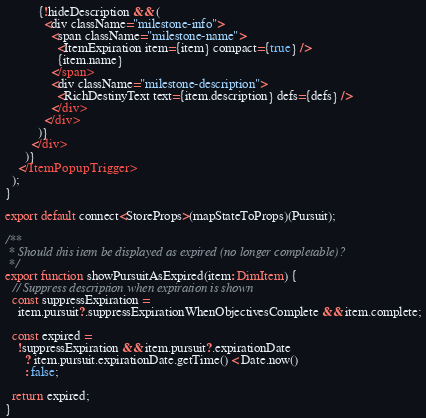Convert code to text. <code><loc_0><loc_0><loc_500><loc_500><_TypeScript_>          {!hideDescription && (
            <div className="milestone-info">
              <span className="milestone-name">
                <ItemExpiration item={item} compact={true} />
                {item.name}
              </span>
              <div className="milestone-description">
                <RichDestinyText text={item.description} defs={defs} />
              </div>
            </div>
          )}
        </div>
      )}
    </ItemPopupTrigger>
  );
}

export default connect<StoreProps>(mapStateToProps)(Pursuit);

/**
 * Should this item be displayed as expired (no longer completable)?
 */
export function showPursuitAsExpired(item: DimItem) {
  // Suppress description when expiration is shown
  const suppressExpiration =
    item.pursuit?.suppressExpirationWhenObjectivesComplete && item.complete;

  const expired =
    !suppressExpiration && item.pursuit?.expirationDate
      ? item.pursuit.expirationDate.getTime() < Date.now()
      : false;

  return expired;
}
</code> 